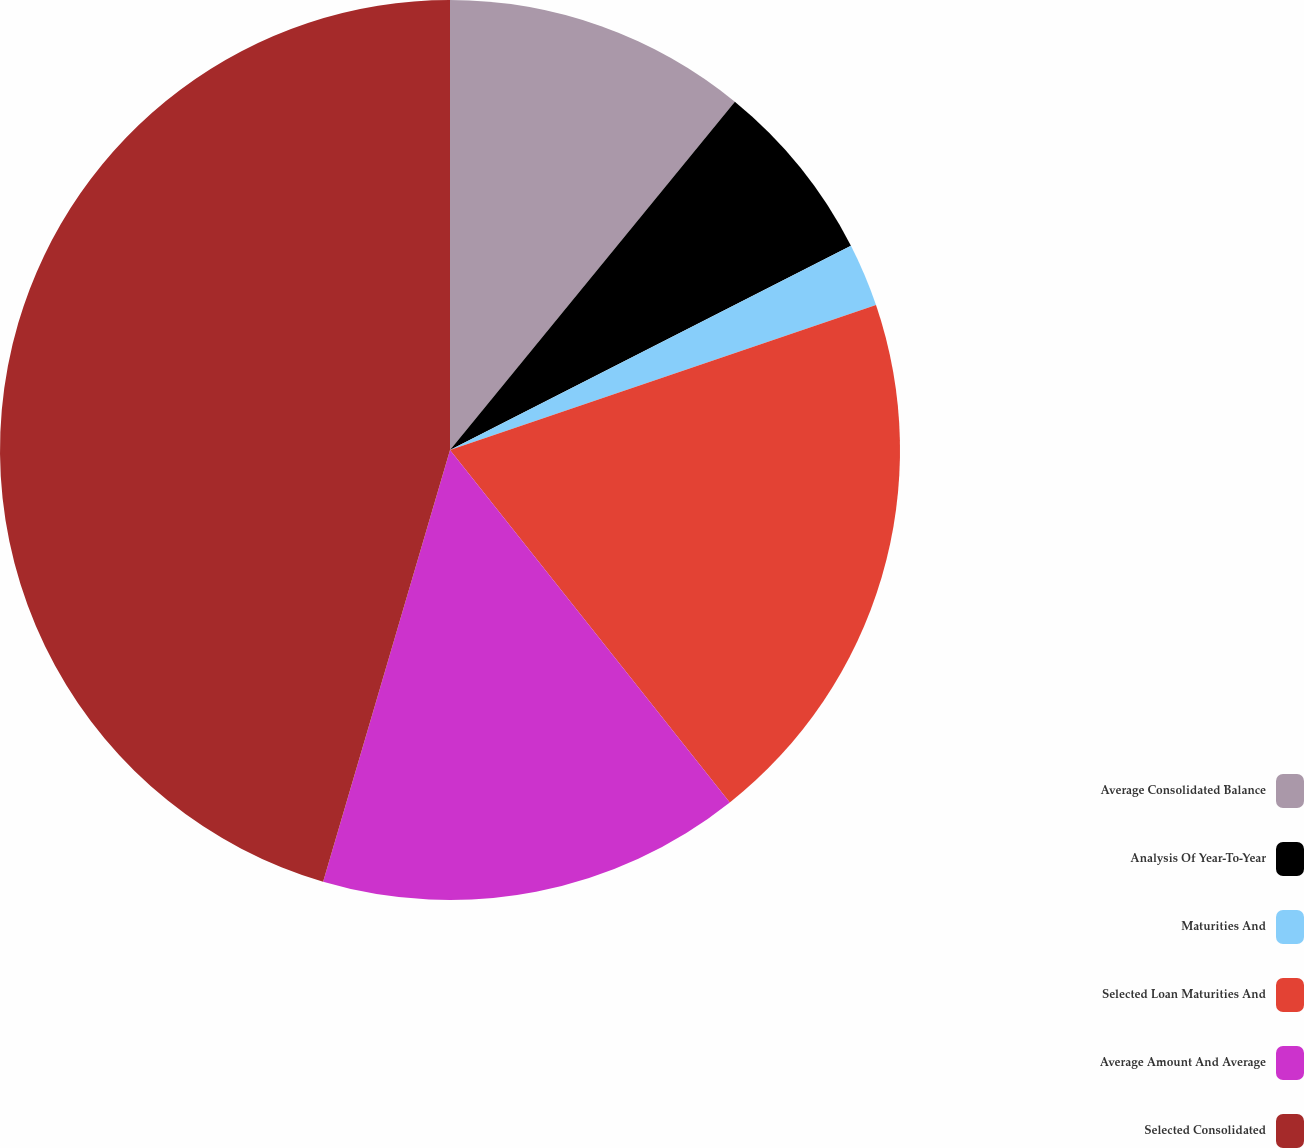Convert chart to OTSL. <chart><loc_0><loc_0><loc_500><loc_500><pie_chart><fcel>Average Consolidated Balance<fcel>Analysis Of Year-To-Year<fcel>Maturities And<fcel>Selected Loan Maturities And<fcel>Average Amount And Average<fcel>Selected Consolidated<nl><fcel>10.91%<fcel>6.59%<fcel>2.28%<fcel>19.54%<fcel>15.23%<fcel>45.45%<nl></chart> 